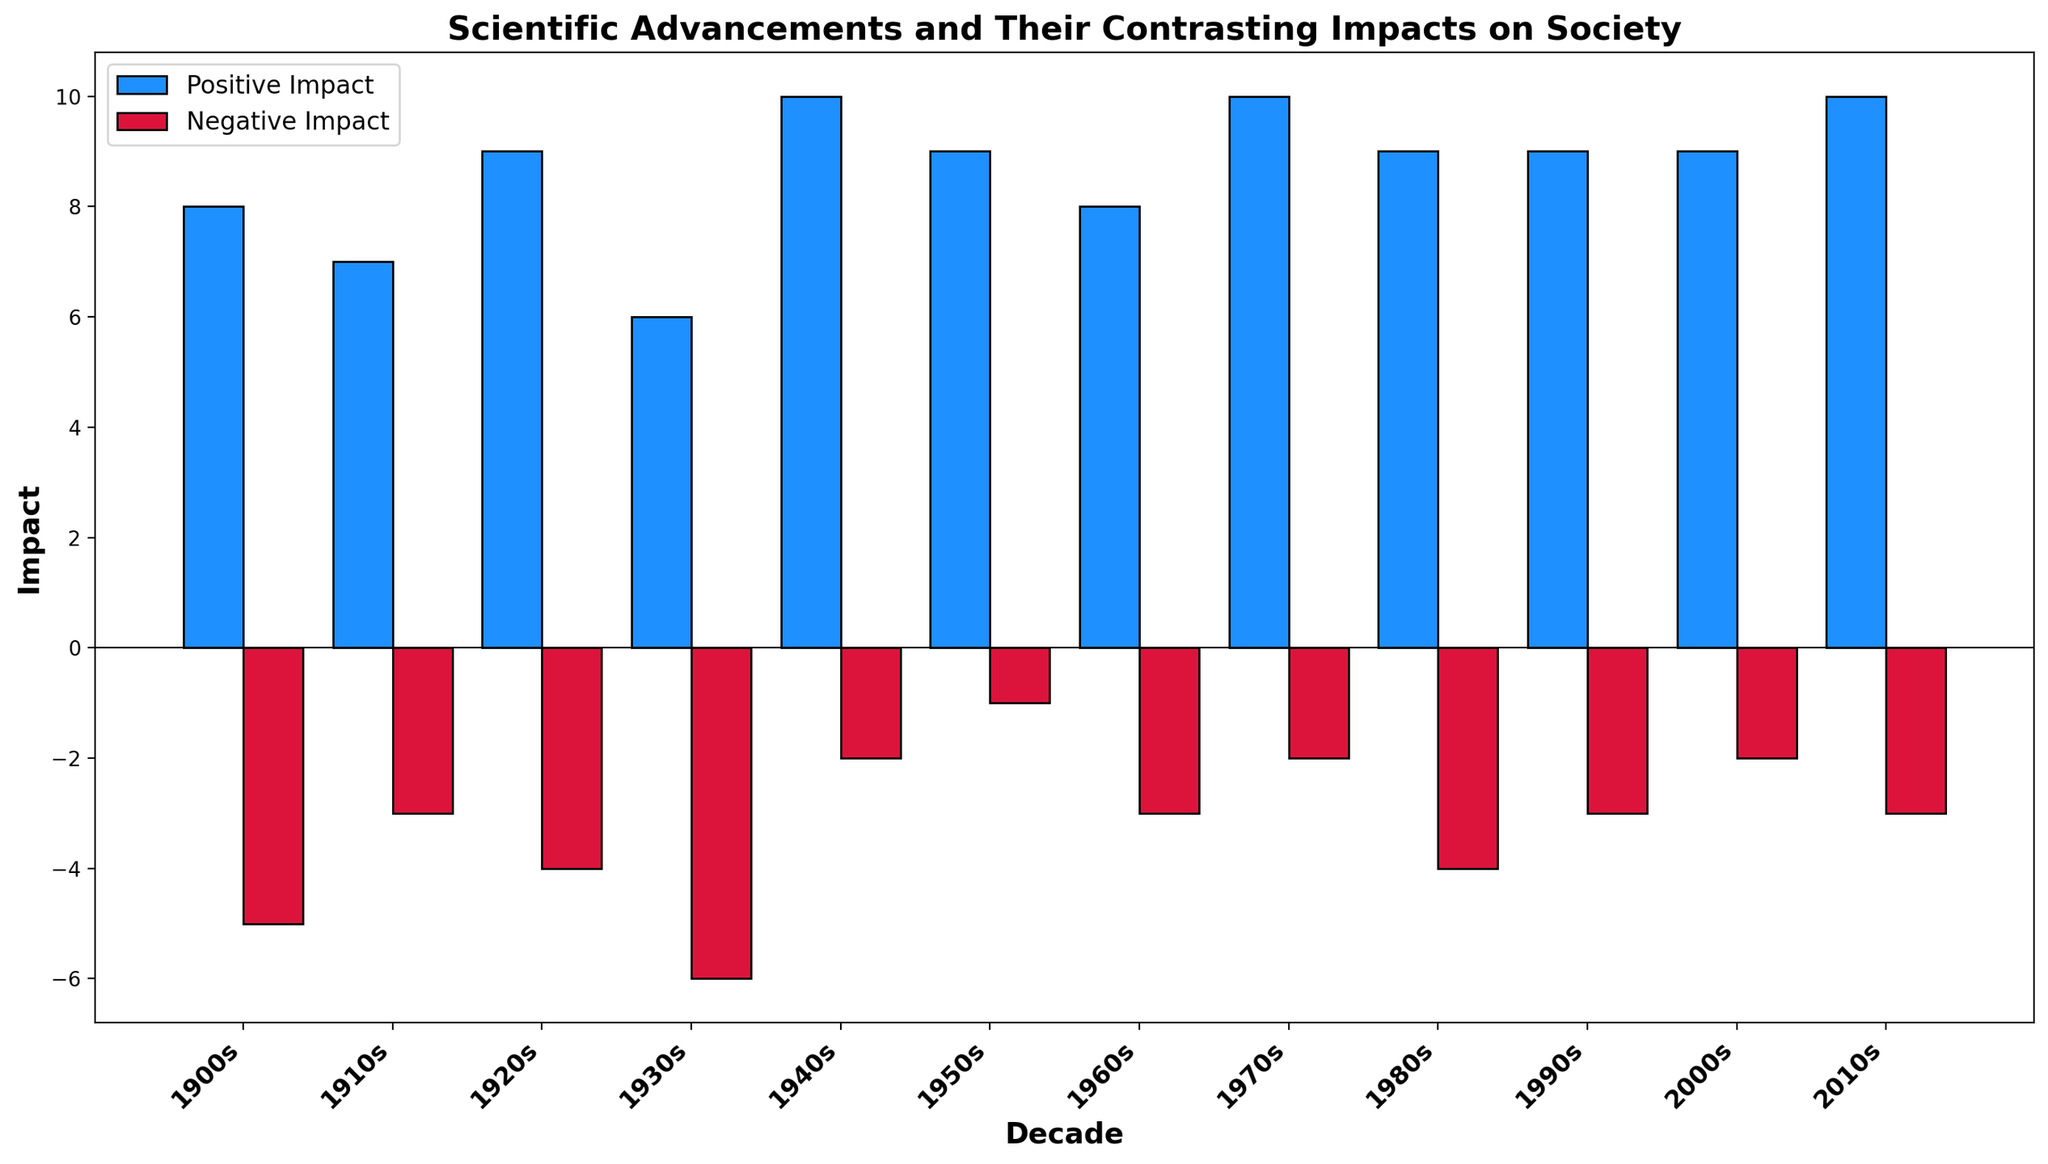What scientific advancement in the 1940s had the most positive impact? The bar representing the 1940s shows the positive impact for the development of antibiotics as 10, which is the highest value for that decade
Answer: Development of Antibiotics Which decade had the highest negative impact associated with an advancement? The 1930s bar for negative impact shows a value of -6, which is the highest (in terms of absolute value) negative impact among all decades
Answer: 1930s In which decade did the advancement in scientific knowledge have both a high positive impact and a low negative impact? For a high positive impact and a low negative impact, we look for high positive bars and small (closer to 0) negative bars. The 1940s and 1950s fit this criteria with positive impacts of 10 and 9 and negative impacts of -2 and -1, respectively
Answer: 1940s and 1950s Which scientific advancement in the early 20th century (1900s to 1930s) had a more balanced impact, meaning minor differences between positive and negative impacts? Comparing Radioactivity Discovery (1900s: 8, -5), General Relativity (1910s: 7, -3), Quantum Mechanics Foundation (1920s: 9, -4), and Nuclear Fission (1930s: 6, -6), General Relativity has the smallest difference between positive and negative impacts (difference of 4)
Answer: General Relativity What is the combined positive impact of scientific advancements during the 1970s and 1980s? The positive impact in the 1970s is 10, and in the 1980s is 9. Summing these gives 10 + 9 = 19
Answer: 19 How do the positive and negative impacts of the 1990s compare with those of the 2000s? For the 1990s, the positive impact is 9 and the negative impact is -3. For the 2000s, the positive impact is 9 and the negative impact is -2. Both decades have the same positive impact of 9, but the negatives differ by 1 with the 1990s being -3 and the 2000s being -2
Answer: The positive impacts are equal; the 1990s have a higher negative impact Which decade showed advancements with the least negative impacts combined? Summing up the negative impacts: 1900s: -5; 1910s: -3; 1920s: -4; 1930s: -6; 1940s: -2; 1950s: -1; 1960s: -3; 1970s: -2; 1980s: -4; 1990s: -3; 2000s: -2; 2010s: -3. The decade with the least combined negative impact is the 1950s: -1
Answer: 1950s 